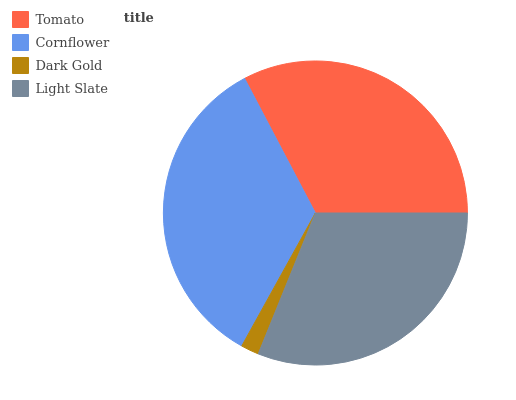Is Dark Gold the minimum?
Answer yes or no. Yes. Is Cornflower the maximum?
Answer yes or no. Yes. Is Cornflower the minimum?
Answer yes or no. No. Is Dark Gold the maximum?
Answer yes or no. No. Is Cornflower greater than Dark Gold?
Answer yes or no. Yes. Is Dark Gold less than Cornflower?
Answer yes or no. Yes. Is Dark Gold greater than Cornflower?
Answer yes or no. No. Is Cornflower less than Dark Gold?
Answer yes or no. No. Is Tomato the high median?
Answer yes or no. Yes. Is Light Slate the low median?
Answer yes or no. Yes. Is Dark Gold the high median?
Answer yes or no. No. Is Cornflower the low median?
Answer yes or no. No. 